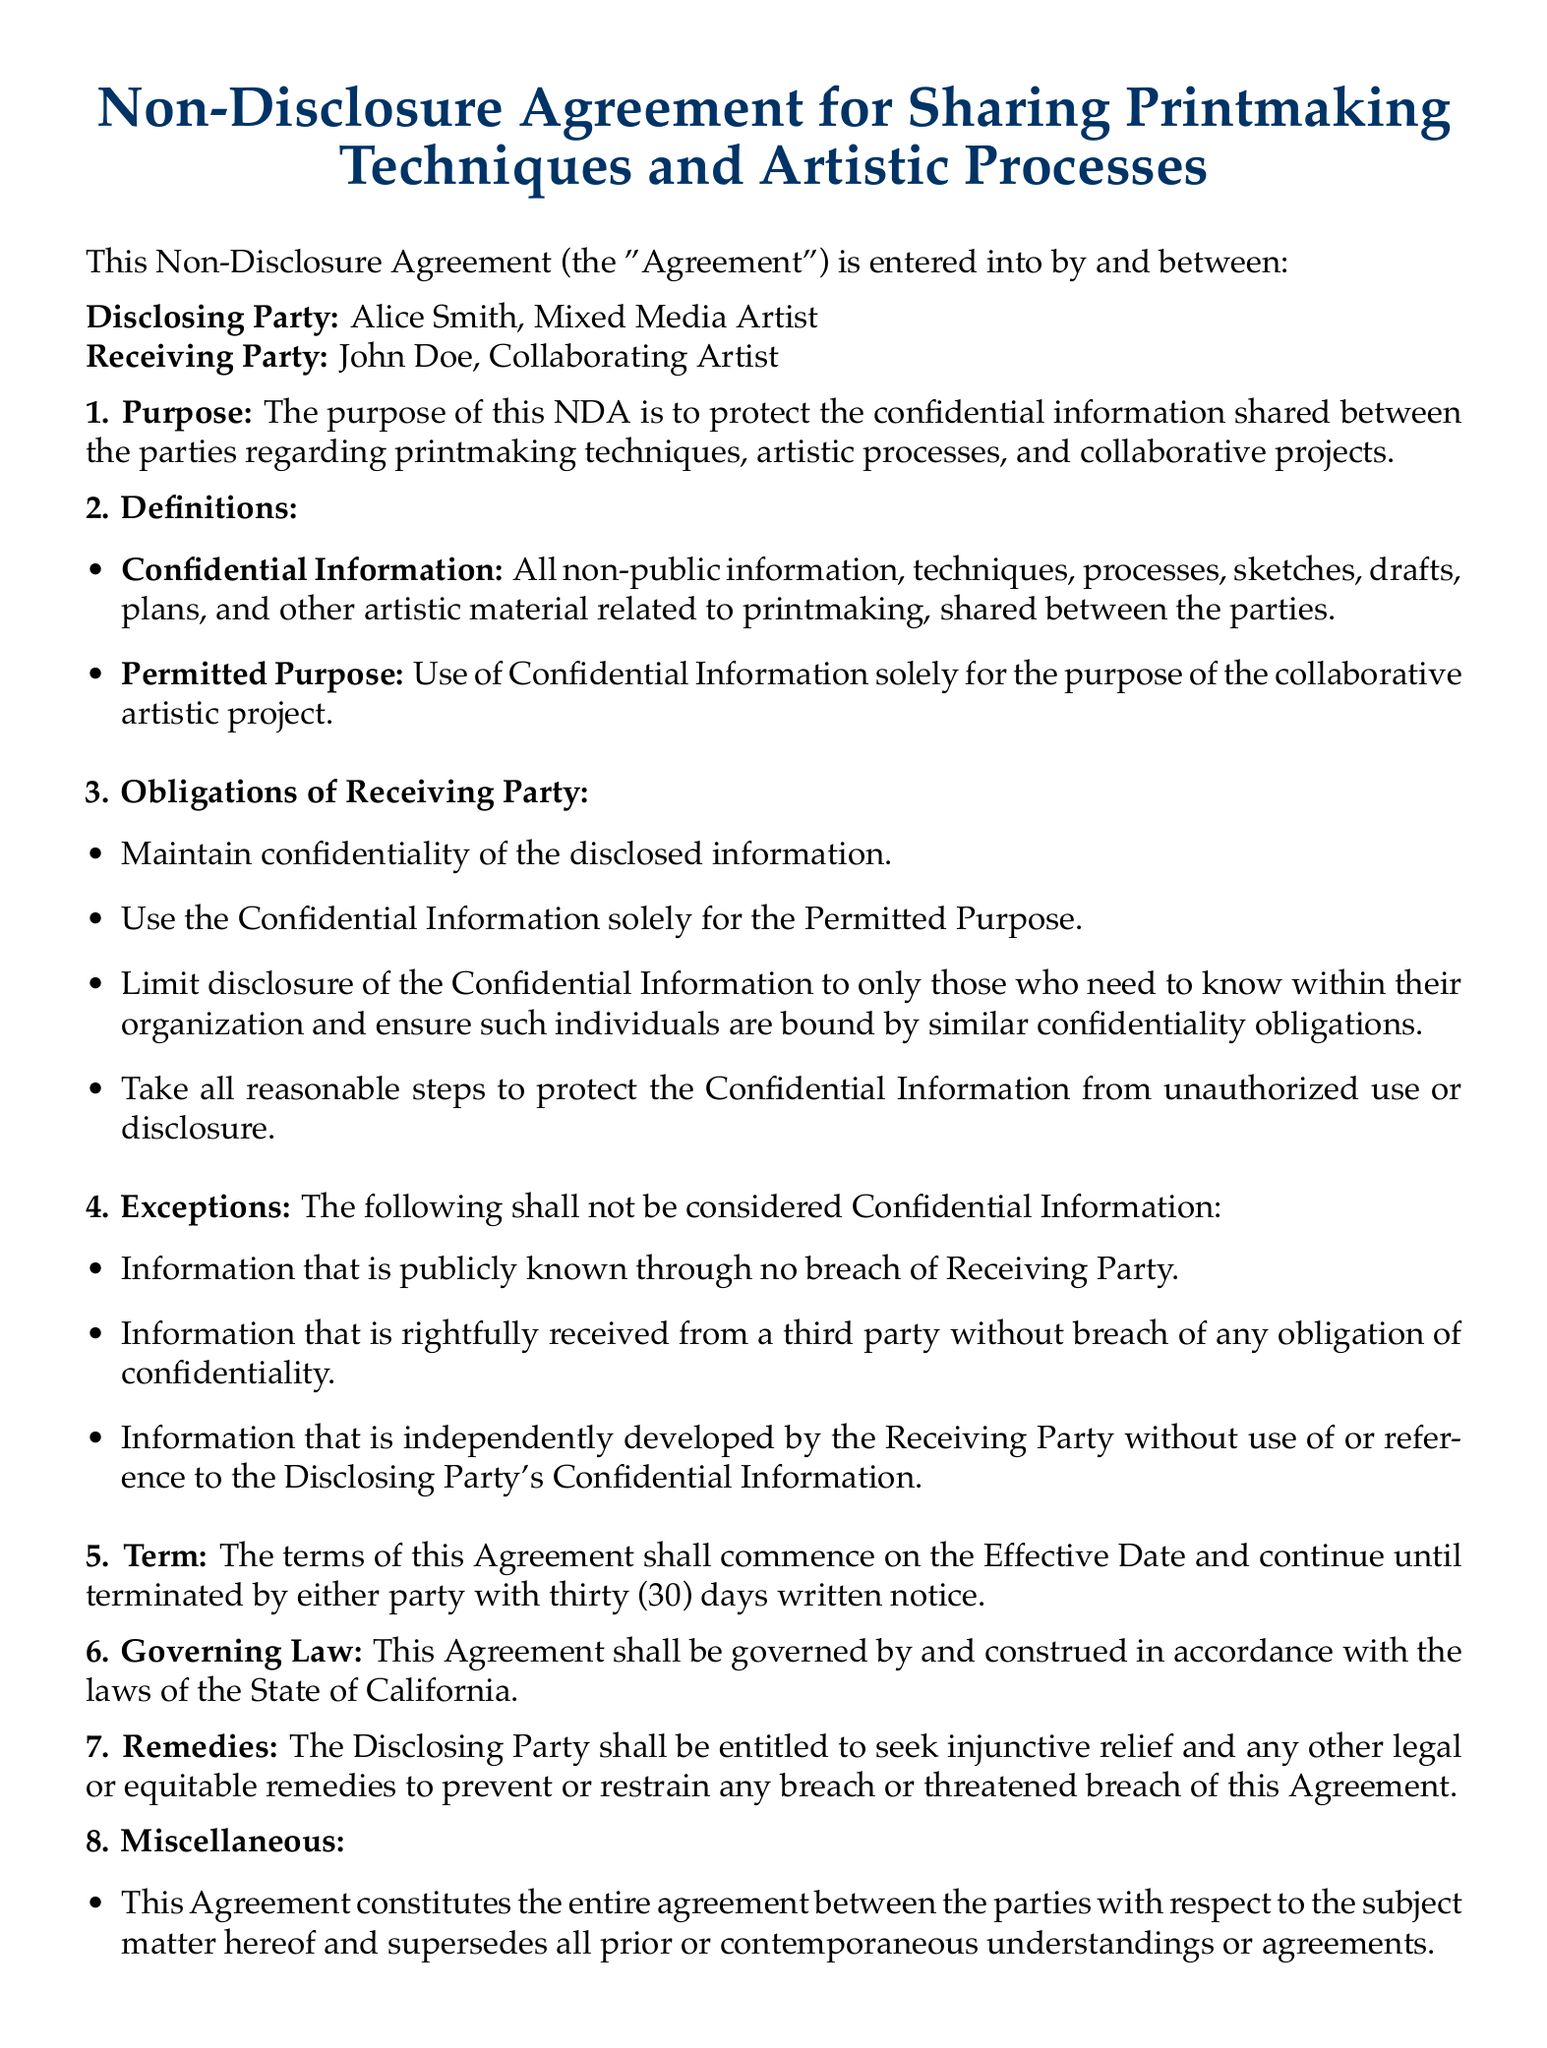What is the title of the document? The title of the document is stated at the top and indicates its purpose as a non-disclosure agreement related to printmaking.
Answer: Non-Disclosure Agreement for Sharing Printmaking Techniques and Artistic Processes Who is the Disclosing Party? The Disclosing Party is specifically named in the agreement.
Answer: Alice Smith, Mixed Media Artist What is the required notice period for termination? The document specifies the notice period required for termination.
Answer: thirty (30) days What is included in the definition of Confidential Information? The document outlines what constitutes Confidential Information within the agreement.
Answer: All non-public information, techniques, processes, sketches, drafts, plans, and other artistic material What is the Governing Law stated in the document? The document contains a clause specifying the jurisdiction governing the agreement.
Answer: the State of California What obligations does the Receiving Party have regarding Confidential Information? The document outlines several responsibilities of the Receiving Party related to confidentiality.
Answer: Maintain confidentiality, use for Permitted Purpose, limit disclosure, protect from unauthorized use What remedies are available to the Disclosing Party? The document specifies what legal actions the Disclosing Party can take in case of a breach.
Answer: Seek injunctive relief and other legal or equitable remedies What is the Effective Date of the Agreement? The Effective Date is mentioned alongside the signatures of both parties.
Answer: 2023-10-05 